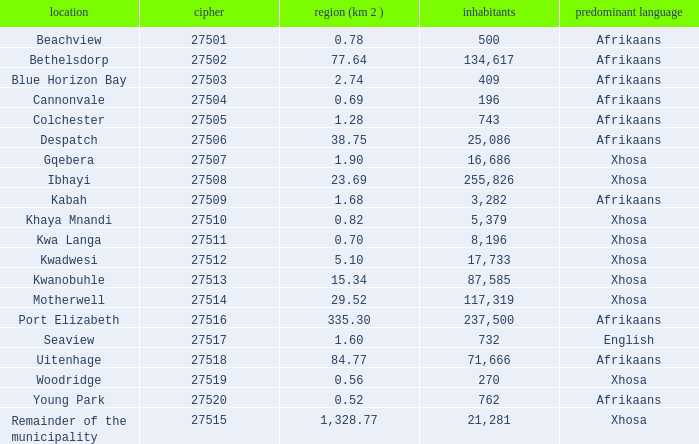What is the place that speaks xhosa, has a population less than 87,585, an area smaller than 1.28 squared kilometers, and a code larger than 27504? Khaya Mnandi, Kwa Langa, Woodridge. 